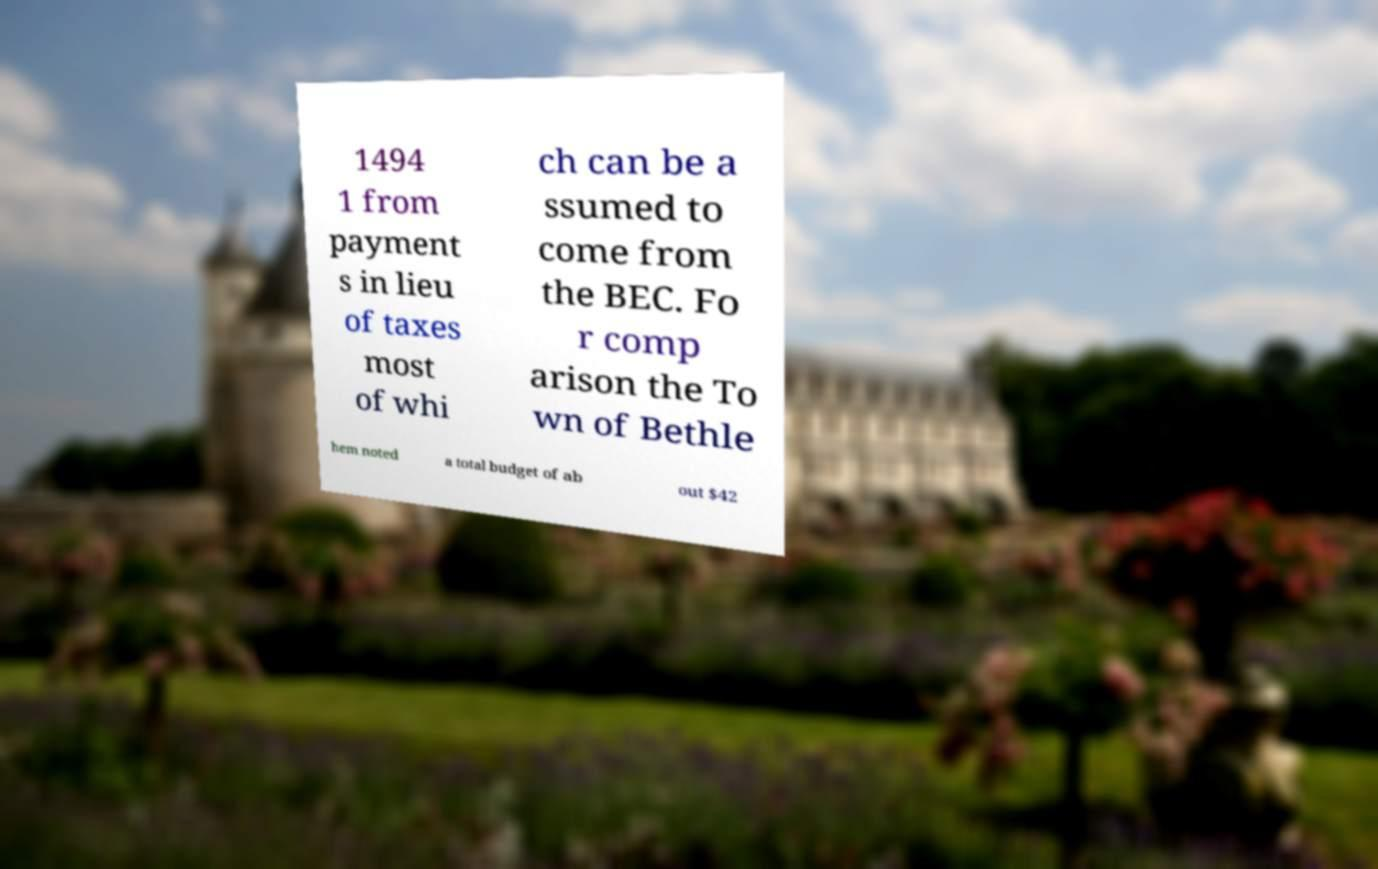I need the written content from this picture converted into text. Can you do that? 1494 1 from payment s in lieu of taxes most of whi ch can be a ssumed to come from the BEC. Fo r comp arison the To wn of Bethle hem noted a total budget of ab out $42 